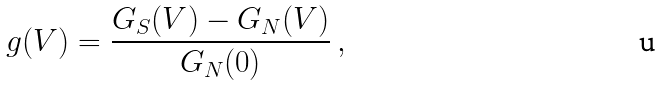<formula> <loc_0><loc_0><loc_500><loc_500>g ( V ) = \frac { G _ { S } ( V ) - G _ { N } ( V ) } { G _ { N } ( 0 ) } \, { , }</formula> 